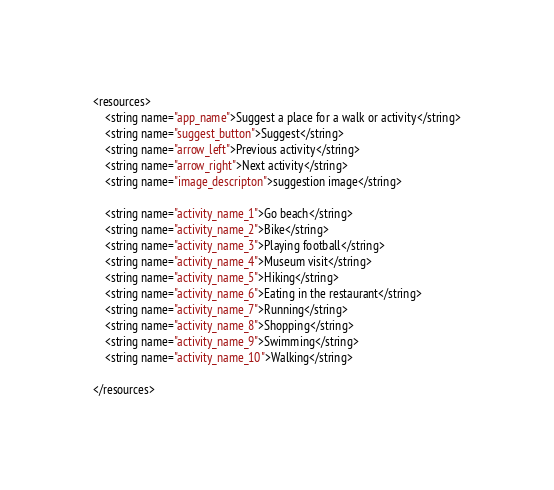Convert code to text. <code><loc_0><loc_0><loc_500><loc_500><_XML_><resources>
    <string name="app_name">Suggest a place for a walk or activity</string>
    <string name="suggest_button">Suggest</string>
    <string name="arrow_left">Previous activity</string>
    <string name="arrow_right">Next activity</string>
    <string name="image_descripton">suggestion image</string>

    <string name="activity_name_1">Go beach</string>
    <string name="activity_name_2">Bike</string>
    <string name="activity_name_3">Playing football</string>
    <string name="activity_name_4">Museum visit</string>
    <string name="activity_name_5">Hiking</string>
    <string name="activity_name_6">Eating in the restaurant</string>
    <string name="activity_name_7">Running</string>
    <string name="activity_name_8">Shopping</string>
    <string name="activity_name_9">Swimming</string>
    <string name="activity_name_10">Walking</string>

</resources></code> 